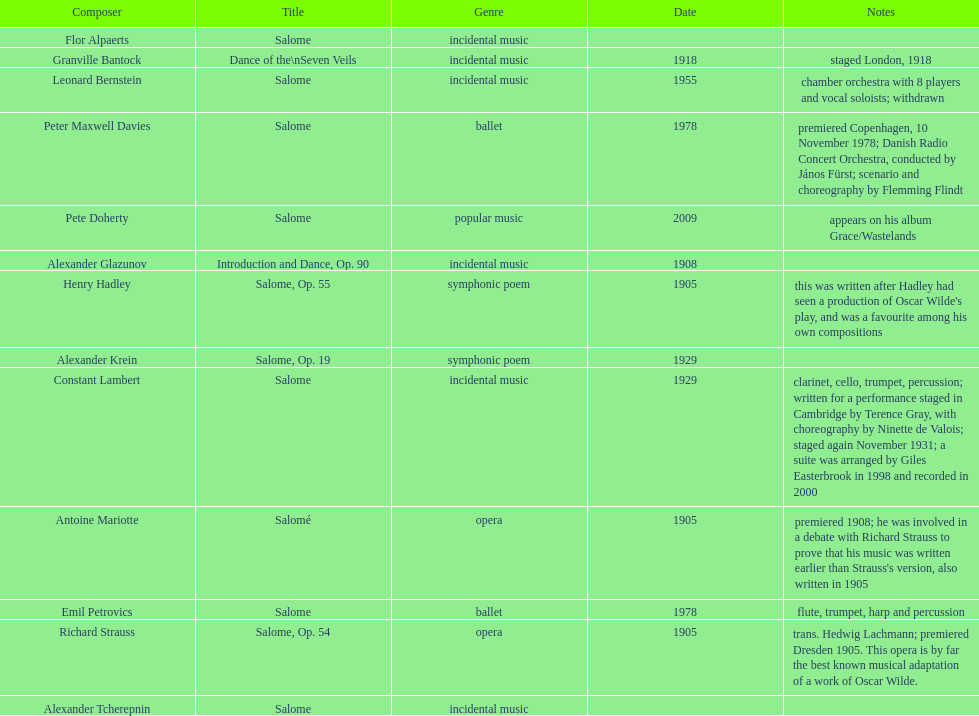What category of genre did peter maxwell davies' piece share with emil petrovics'? Ballet. 